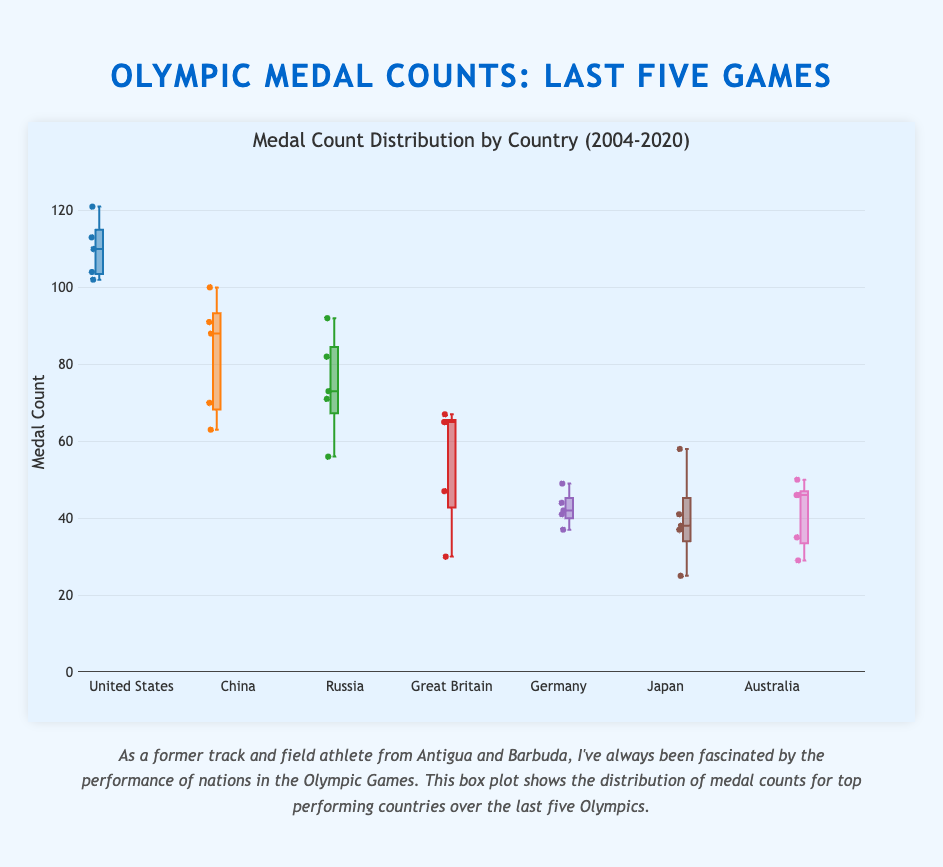What is the title of the box plot? The title is located at the top of the figure and summarises what the figure is about. The title is "Medal Count Distribution by Country (2004-2020)"
Answer: Medal Count Distribution by Country (2004-2020) Which country has the highest median medal count? The median is the middle value of the sorted medal counts for each country as represented by the line inside the box of the box plot. The United States has the highest median as its line is higher compared to other countries' boxes.
Answer: United States What is the range of the y-axis? The y-axis range can be found on the left side of the plot, showing the span of the medal counts. It ranges from 0 to 130.
Answer: 0 to 130 Which country's medal count shows the greatest variability? The variability can be found by looking at the length of the boxes (interquartile range) and the spread of outliers for each country. China has the most extended box and outliers spread, indicating the greatest variability.
Answer: China Which country has the lowest highest medal count value? The lowest highest medal count value is represented by the top whisker of the box plot. Japan's top whisker reaches the lowest maximum value compared to others.
Answer: Japan How do the median medal counts of the United States and China compare? The comparison involves looking at the positions of the median lines inside the boxes for each country. The median for the United States is higher than that for China.
Answer: United States is higher Which country shows an increase in medal count from 2016 to 2020? This involves looking at the individual data points plotted for each year. For Japan, the medal count increased from 41 in 2016 to 58 in 2020.
Answer: Japan Are there any countries with a medal count below 30? By scanning the y-axis values and looking at the data points, we see that no country has a medal count below 30 as all the data points are above this value.
Answer: No What is the mean medal count of Russia over the five Olympics? To calculate the mean, sum the medal counts for Russia for the five years and then divide by the number of years. (92 + 73 + 82 + 56 + 71) / 5 = 374 / 5 = 74.8
Answer: 74.8 Compare the upper quartiles of Great Britain and Germany. The upper quartile is the top edge of the box in each box plot. Great Britain's upper quartile is higher than Germany's, signifying that more of its medal counts are above Germany's upper quartile.
Answer: Great Britain is higher 